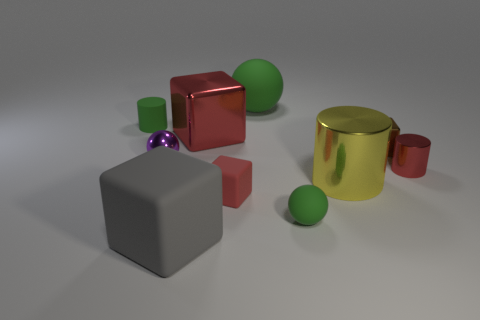Subtract all cubes. How many objects are left? 6 Add 8 small purple balls. How many small purple balls are left? 9 Add 2 tiny red objects. How many tiny red objects exist? 4 Subtract 0 purple cylinders. How many objects are left? 10 Subtract all red objects. Subtract all small cubes. How many objects are left? 5 